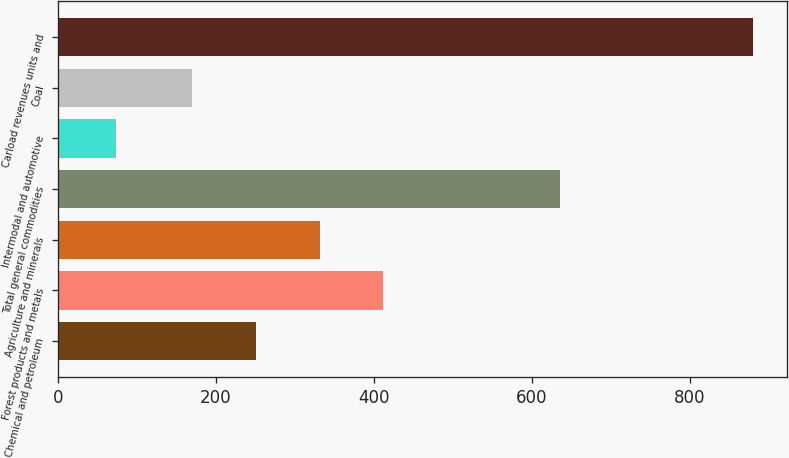<chart> <loc_0><loc_0><loc_500><loc_500><bar_chart><fcel>Chemical and petroleum<fcel>Forest products and metals<fcel>Agriculture and minerals<fcel>Total general commodities<fcel>Intermodal and automotive<fcel>Coal<fcel>Carload revenues units and<nl><fcel>250.84<fcel>411.92<fcel>331.38<fcel>635.1<fcel>74.1<fcel>170.3<fcel>879.5<nl></chart> 